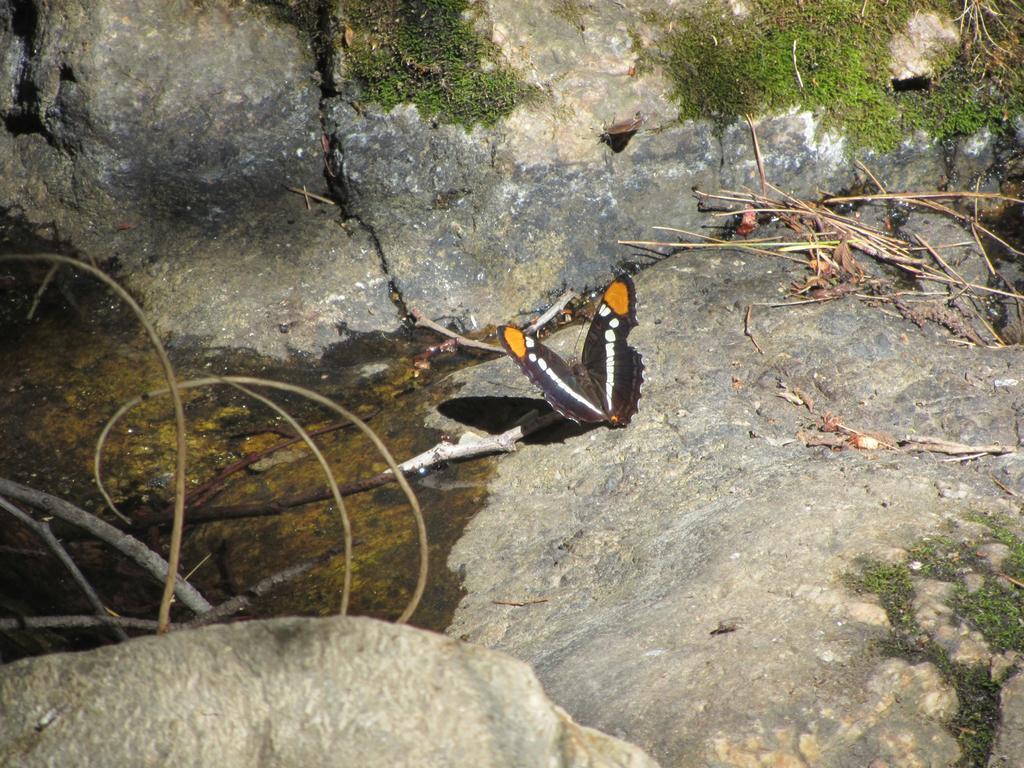Please provide a concise description of this image. In this image we can see butterflies on the rock. 